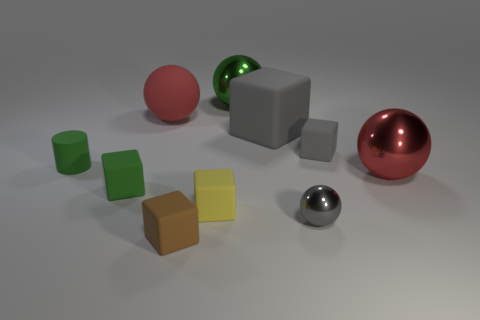There is a small object that is the same color as the small metal ball; what is it made of?
Ensure brevity in your answer.  Rubber. Does the matte block right of the tiny gray sphere have the same color as the big block?
Offer a very short reply. Yes. There is a small gray thing in front of the large metallic ball that is in front of the small rubber cylinder; is there a tiny rubber object right of it?
Provide a short and direct response. Yes. There is a green object that is the same size as the rubber ball; what is its shape?
Give a very brief answer. Sphere. How many other things are the same color as the tiny shiny sphere?
Make the answer very short. 2. What material is the gray sphere?
Provide a short and direct response. Metal. How many other objects are the same material as the small yellow thing?
Your answer should be very brief. 6. There is a metallic thing that is in front of the tiny gray rubber cube and behind the small yellow matte object; what size is it?
Provide a succinct answer. Large. There is a tiny green thing that is to the right of the thing left of the green matte cube; what shape is it?
Your answer should be very brief. Cube. Is the number of green rubber things that are in front of the brown cube the same as the number of gray rubber spheres?
Make the answer very short. Yes. 